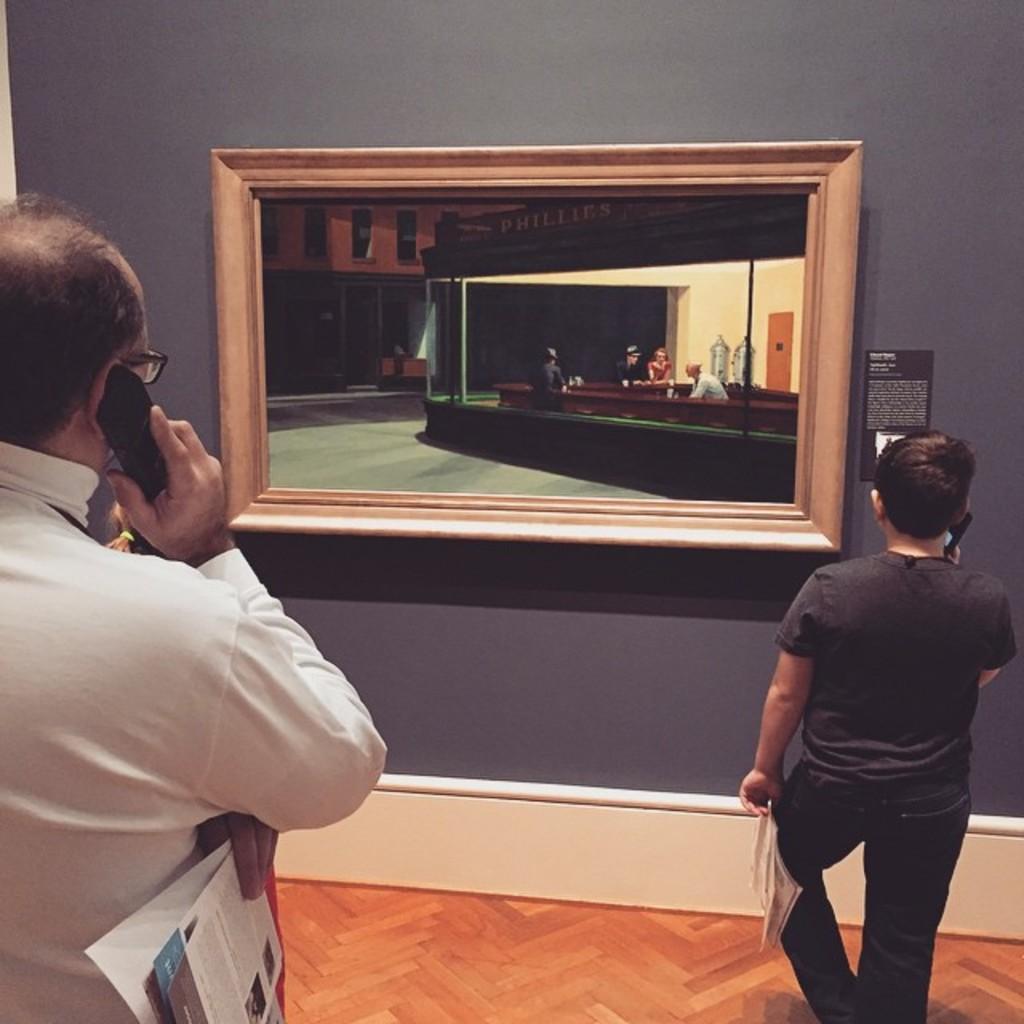Describe this image in one or two sentences. In this image we can see two people standing and holding mobile phone. In the background of the image there is wall. There is a photo frame. At the bottom of the image there is carpet. 